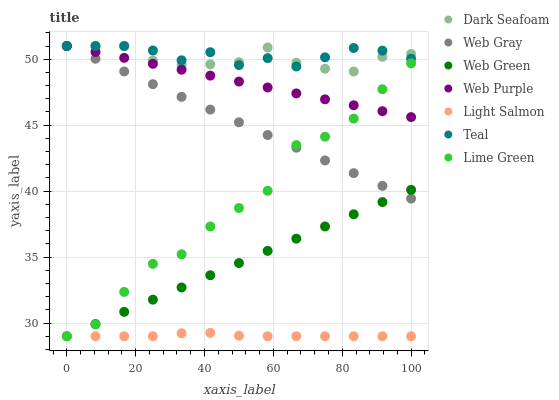Does Light Salmon have the minimum area under the curve?
Answer yes or no. Yes. Does Teal have the maximum area under the curve?
Answer yes or no. Yes. Does Web Gray have the minimum area under the curve?
Answer yes or no. No. Does Web Gray have the maximum area under the curve?
Answer yes or no. No. Is Web Green the smoothest?
Answer yes or no. Yes. Is Lime Green the roughest?
Answer yes or no. Yes. Is Web Gray the smoothest?
Answer yes or no. No. Is Web Gray the roughest?
Answer yes or no. No. Does Light Salmon have the lowest value?
Answer yes or no. Yes. Does Web Gray have the lowest value?
Answer yes or no. No. Does Teal have the highest value?
Answer yes or no. Yes. Does Web Green have the highest value?
Answer yes or no. No. Is Light Salmon less than Web Gray?
Answer yes or no. Yes. Is Dark Seafoam greater than Web Green?
Answer yes or no. Yes. Does Dark Seafoam intersect Teal?
Answer yes or no. Yes. Is Dark Seafoam less than Teal?
Answer yes or no. No. Is Dark Seafoam greater than Teal?
Answer yes or no. No. Does Light Salmon intersect Web Gray?
Answer yes or no. No. 